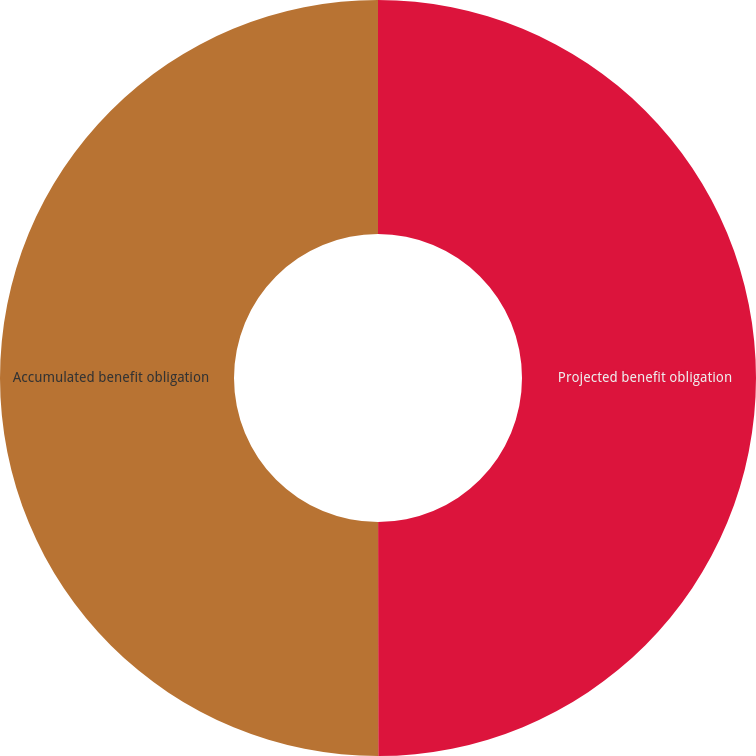Convert chart. <chart><loc_0><loc_0><loc_500><loc_500><pie_chart><fcel>Projected benefit obligation<fcel>Accumulated benefit obligation<nl><fcel>49.99%<fcel>50.01%<nl></chart> 